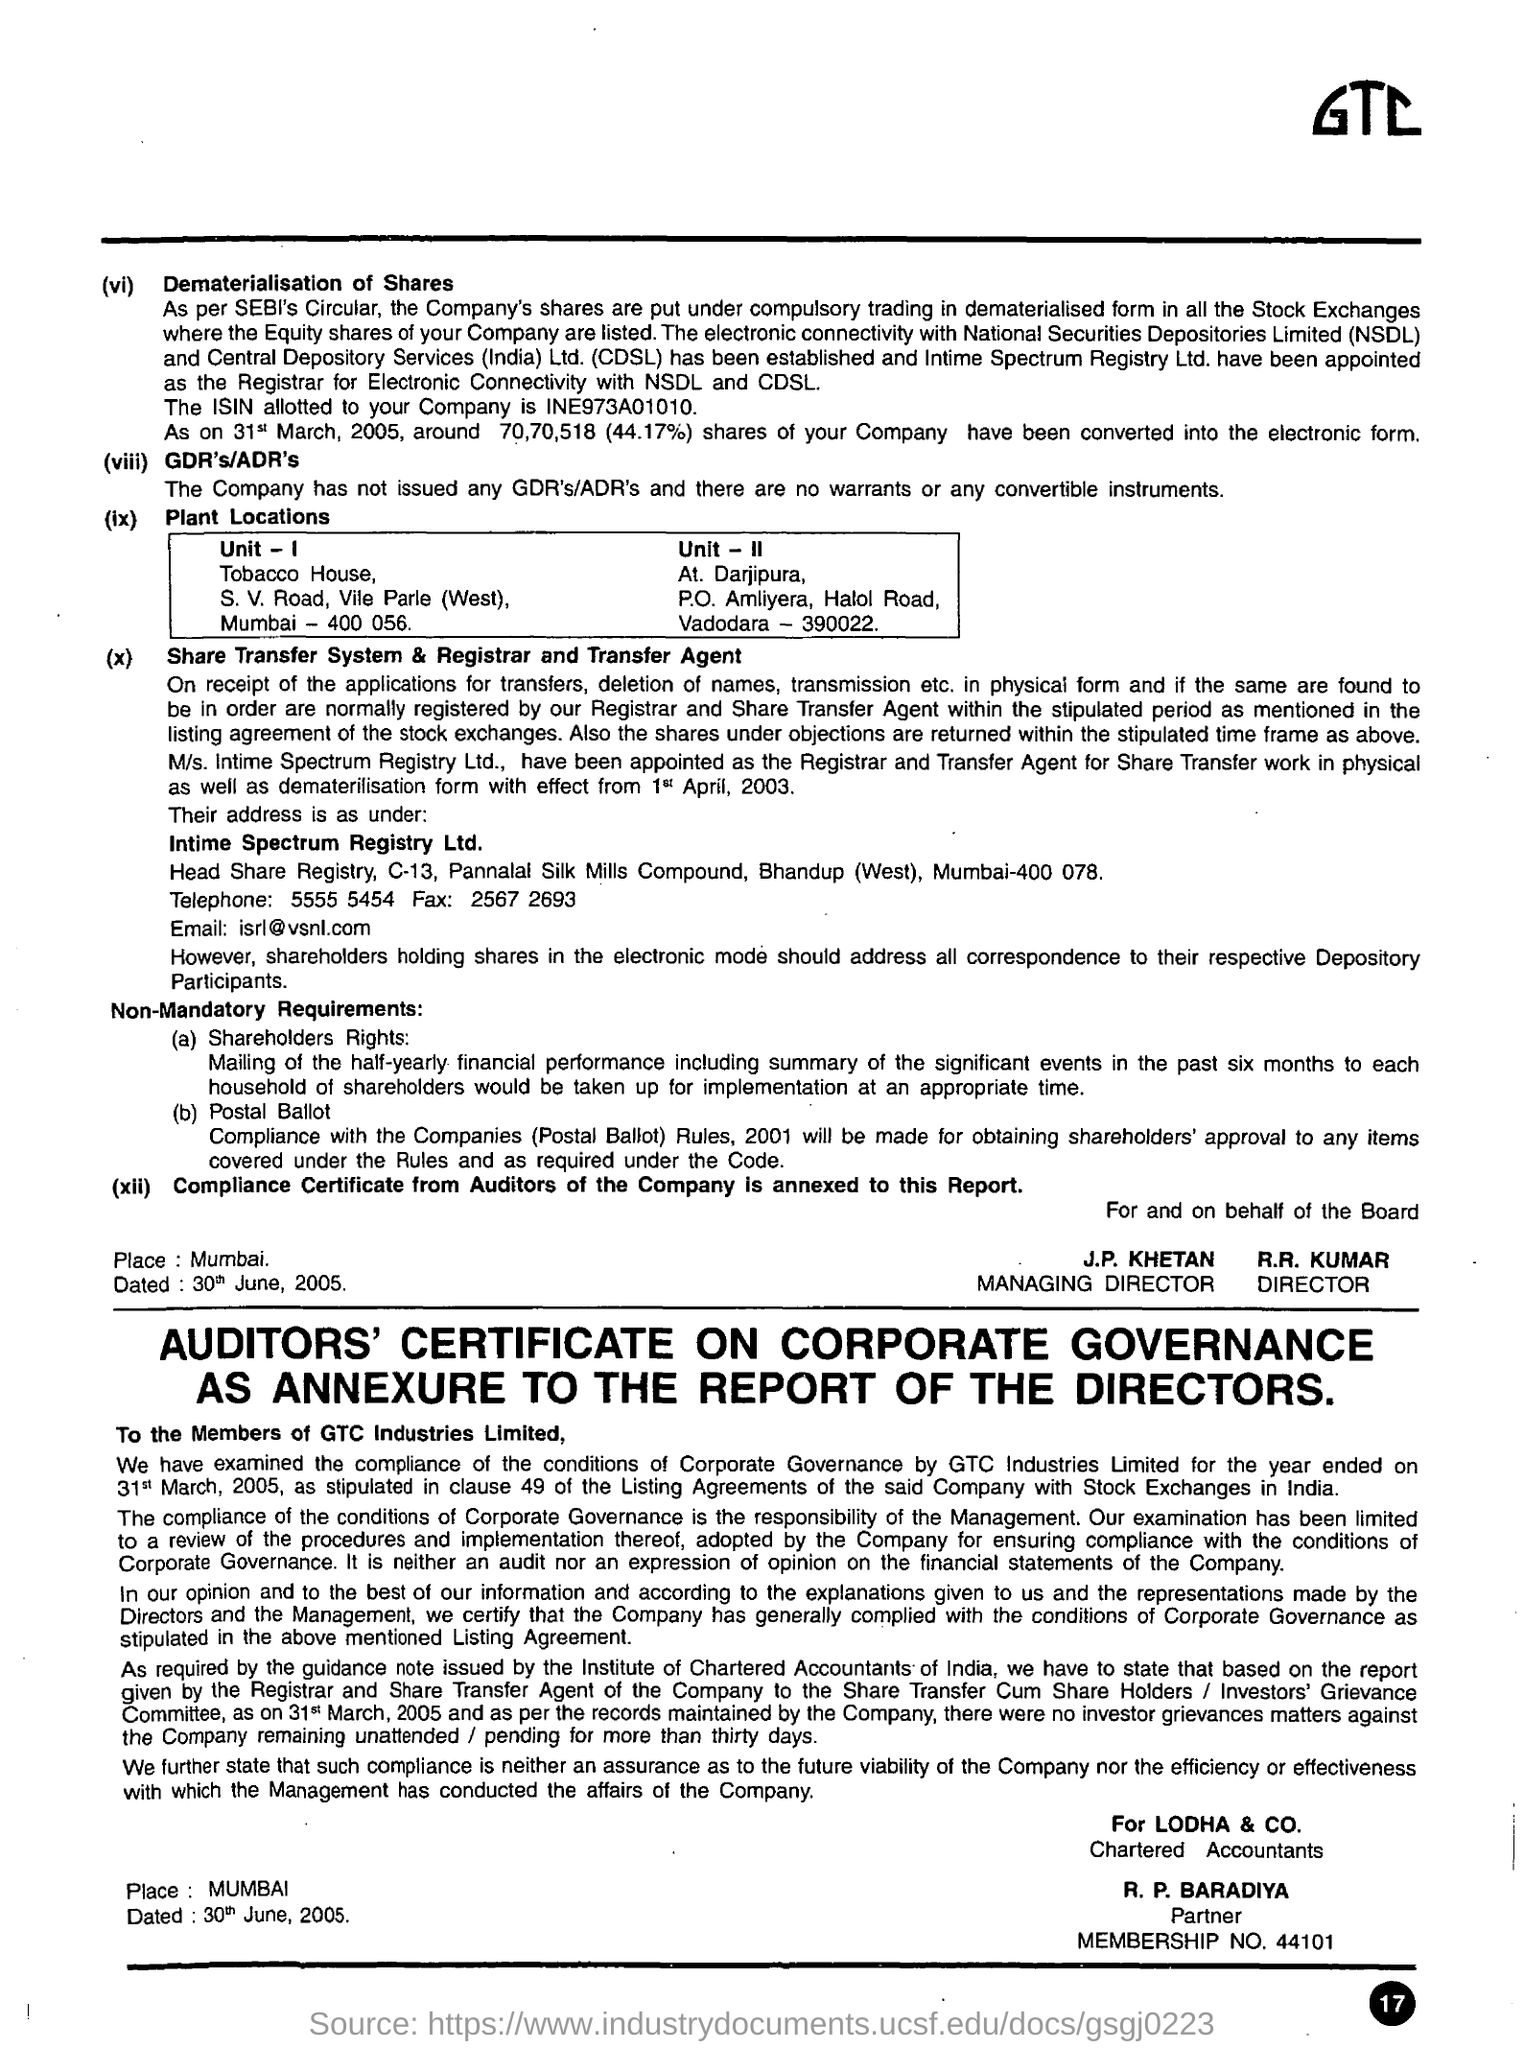Specify some key components in this picture. The City for Plant Location Unit is located in Mumbai. The City for Plant Location Unit - II is located in Vadodara. 